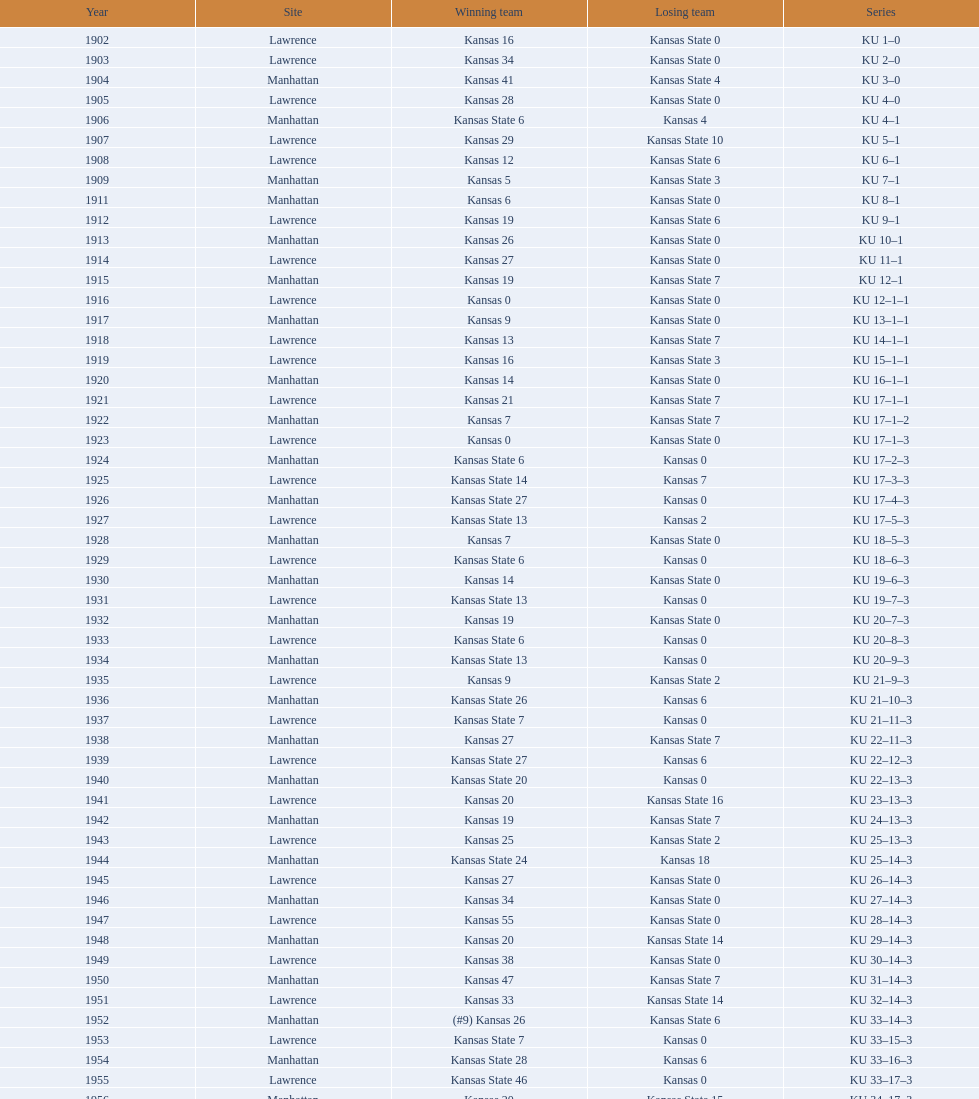Who had the most wins in the 1950's: kansas or kansas state? Kansas. 